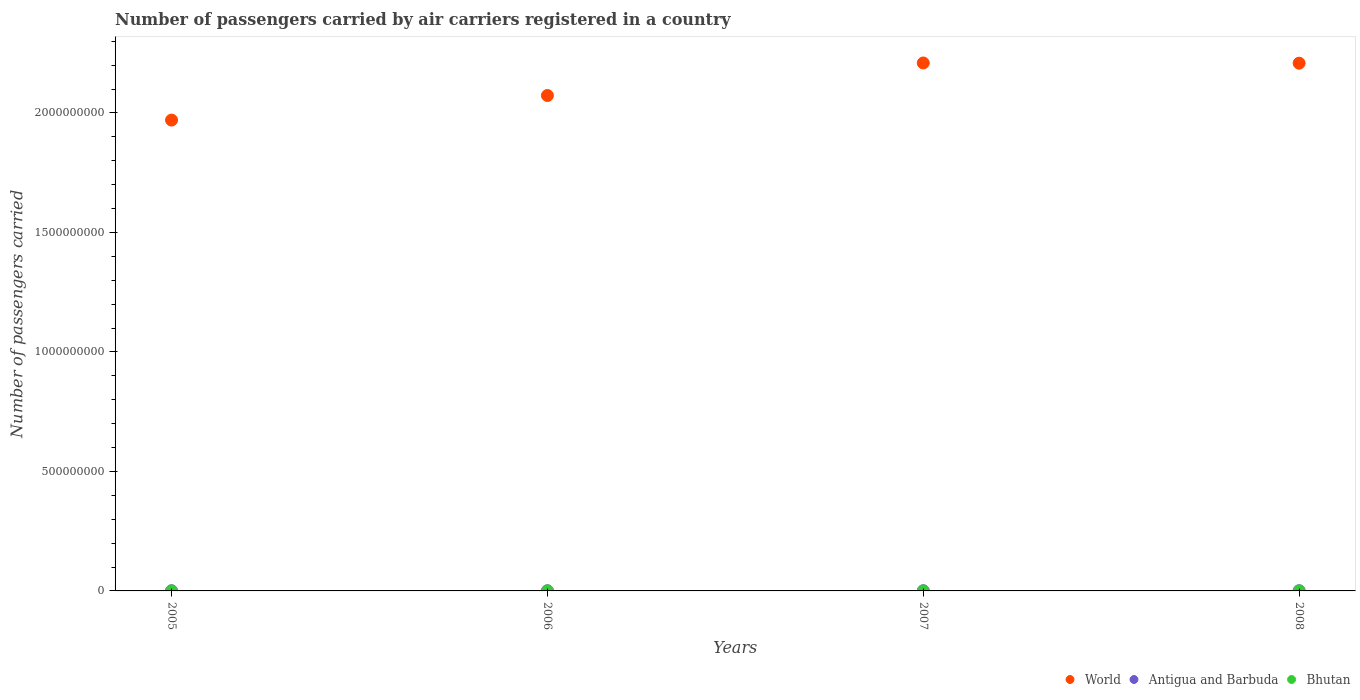How many different coloured dotlines are there?
Keep it short and to the point. 3. What is the number of passengers carried by air carriers in Bhutan in 2008?
Your response must be concise. 5.28e+04. Across all years, what is the maximum number of passengers carried by air carriers in World?
Provide a short and direct response. 2.21e+09. Across all years, what is the minimum number of passengers carried by air carriers in World?
Your answer should be very brief. 1.97e+09. In which year was the number of passengers carried by air carriers in World maximum?
Provide a succinct answer. 2007. What is the total number of passengers carried by air carriers in Antigua and Barbuda in the graph?
Offer a very short reply. 3.15e+06. What is the difference between the number of passengers carried by air carriers in World in 2005 and that in 2007?
Ensure brevity in your answer.  -2.39e+08. What is the difference between the number of passengers carried by air carriers in Antigua and Barbuda in 2006 and the number of passengers carried by air carriers in Bhutan in 2007?
Ensure brevity in your answer.  7.01e+05. What is the average number of passengers carried by air carriers in Antigua and Barbuda per year?
Your answer should be compact. 7.87e+05. In the year 2007, what is the difference between the number of passengers carried by air carriers in World and number of passengers carried by air carriers in Antigua and Barbuda?
Keep it short and to the point. 2.21e+09. What is the ratio of the number of passengers carried by air carriers in Bhutan in 2005 to that in 2007?
Offer a very short reply. 0.92. Is the difference between the number of passengers carried by air carriers in World in 2007 and 2008 greater than the difference between the number of passengers carried by air carriers in Antigua and Barbuda in 2007 and 2008?
Offer a terse response. Yes. What is the difference between the highest and the second highest number of passengers carried by air carriers in World?
Make the answer very short. 9.18e+05. What is the difference between the highest and the lowest number of passengers carried by air carriers in Antigua and Barbuda?
Your response must be concise. 5.81e+04. In how many years, is the number of passengers carried by air carriers in Bhutan greater than the average number of passengers carried by air carriers in Bhutan taken over all years?
Your answer should be compact. 2. Is the number of passengers carried by air carriers in Antigua and Barbuda strictly greater than the number of passengers carried by air carriers in Bhutan over the years?
Offer a terse response. Yes. Is the number of passengers carried by air carriers in Bhutan strictly less than the number of passengers carried by air carriers in Antigua and Barbuda over the years?
Provide a short and direct response. Yes. What is the difference between two consecutive major ticks on the Y-axis?
Your answer should be compact. 5.00e+08. What is the title of the graph?
Provide a short and direct response. Number of passengers carried by air carriers registered in a country. Does "Central African Republic" appear as one of the legend labels in the graph?
Offer a terse response. No. What is the label or title of the X-axis?
Offer a terse response. Years. What is the label or title of the Y-axis?
Your response must be concise. Number of passengers carried. What is the Number of passengers carried of World in 2005?
Your response must be concise. 1.97e+09. What is the Number of passengers carried of Antigua and Barbuda in 2005?
Give a very brief answer. 7.78e+05. What is the Number of passengers carried of Bhutan in 2005?
Keep it short and to the point. 4.91e+04. What is the Number of passengers carried in World in 2006?
Ensure brevity in your answer.  2.07e+09. What is the Number of passengers carried of Antigua and Barbuda in 2006?
Keep it short and to the point. 7.55e+05. What is the Number of passengers carried of Bhutan in 2006?
Keep it short and to the point. 5.11e+04. What is the Number of passengers carried of World in 2007?
Make the answer very short. 2.21e+09. What is the Number of passengers carried of Antigua and Barbuda in 2007?
Provide a succinct answer. 8.00e+05. What is the Number of passengers carried in Bhutan in 2007?
Give a very brief answer. 5.36e+04. What is the Number of passengers carried of World in 2008?
Give a very brief answer. 2.21e+09. What is the Number of passengers carried in Antigua and Barbuda in 2008?
Your answer should be compact. 8.13e+05. What is the Number of passengers carried of Bhutan in 2008?
Keep it short and to the point. 5.28e+04. Across all years, what is the maximum Number of passengers carried of World?
Offer a terse response. 2.21e+09. Across all years, what is the maximum Number of passengers carried in Antigua and Barbuda?
Provide a succinct answer. 8.13e+05. Across all years, what is the maximum Number of passengers carried of Bhutan?
Provide a succinct answer. 5.36e+04. Across all years, what is the minimum Number of passengers carried of World?
Your answer should be compact. 1.97e+09. Across all years, what is the minimum Number of passengers carried in Antigua and Barbuda?
Provide a short and direct response. 7.55e+05. Across all years, what is the minimum Number of passengers carried in Bhutan?
Keep it short and to the point. 4.91e+04. What is the total Number of passengers carried in World in the graph?
Provide a short and direct response. 8.46e+09. What is the total Number of passengers carried of Antigua and Barbuda in the graph?
Your answer should be compact. 3.15e+06. What is the total Number of passengers carried of Bhutan in the graph?
Ensure brevity in your answer.  2.07e+05. What is the difference between the Number of passengers carried of World in 2005 and that in 2006?
Ensure brevity in your answer.  -1.03e+08. What is the difference between the Number of passengers carried of Antigua and Barbuda in 2005 and that in 2006?
Provide a succinct answer. 2.33e+04. What is the difference between the Number of passengers carried in Bhutan in 2005 and that in 2006?
Ensure brevity in your answer.  -1964. What is the difference between the Number of passengers carried of World in 2005 and that in 2007?
Offer a very short reply. -2.39e+08. What is the difference between the Number of passengers carried in Antigua and Barbuda in 2005 and that in 2007?
Your answer should be compact. -2.19e+04. What is the difference between the Number of passengers carried of Bhutan in 2005 and that in 2007?
Keep it short and to the point. -4517. What is the difference between the Number of passengers carried in World in 2005 and that in 2008?
Ensure brevity in your answer.  -2.38e+08. What is the difference between the Number of passengers carried in Antigua and Barbuda in 2005 and that in 2008?
Provide a short and direct response. -3.48e+04. What is the difference between the Number of passengers carried of Bhutan in 2005 and that in 2008?
Your response must be concise. -3713. What is the difference between the Number of passengers carried in World in 2006 and that in 2007?
Your answer should be very brief. -1.36e+08. What is the difference between the Number of passengers carried of Antigua and Barbuda in 2006 and that in 2007?
Provide a succinct answer. -4.53e+04. What is the difference between the Number of passengers carried in Bhutan in 2006 and that in 2007?
Your answer should be compact. -2553. What is the difference between the Number of passengers carried in World in 2006 and that in 2008?
Ensure brevity in your answer.  -1.35e+08. What is the difference between the Number of passengers carried of Antigua and Barbuda in 2006 and that in 2008?
Your response must be concise. -5.81e+04. What is the difference between the Number of passengers carried in Bhutan in 2006 and that in 2008?
Ensure brevity in your answer.  -1749. What is the difference between the Number of passengers carried in World in 2007 and that in 2008?
Provide a succinct answer. 9.18e+05. What is the difference between the Number of passengers carried in Antigua and Barbuda in 2007 and that in 2008?
Keep it short and to the point. -1.28e+04. What is the difference between the Number of passengers carried of Bhutan in 2007 and that in 2008?
Your response must be concise. 804. What is the difference between the Number of passengers carried of World in 2005 and the Number of passengers carried of Antigua and Barbuda in 2006?
Give a very brief answer. 1.97e+09. What is the difference between the Number of passengers carried in World in 2005 and the Number of passengers carried in Bhutan in 2006?
Make the answer very short. 1.97e+09. What is the difference between the Number of passengers carried in Antigua and Barbuda in 2005 and the Number of passengers carried in Bhutan in 2006?
Your answer should be compact. 7.27e+05. What is the difference between the Number of passengers carried of World in 2005 and the Number of passengers carried of Antigua and Barbuda in 2007?
Offer a terse response. 1.97e+09. What is the difference between the Number of passengers carried in World in 2005 and the Number of passengers carried in Bhutan in 2007?
Make the answer very short. 1.97e+09. What is the difference between the Number of passengers carried in Antigua and Barbuda in 2005 and the Number of passengers carried in Bhutan in 2007?
Keep it short and to the point. 7.25e+05. What is the difference between the Number of passengers carried in World in 2005 and the Number of passengers carried in Antigua and Barbuda in 2008?
Ensure brevity in your answer.  1.97e+09. What is the difference between the Number of passengers carried in World in 2005 and the Number of passengers carried in Bhutan in 2008?
Your response must be concise. 1.97e+09. What is the difference between the Number of passengers carried in Antigua and Barbuda in 2005 and the Number of passengers carried in Bhutan in 2008?
Your answer should be compact. 7.25e+05. What is the difference between the Number of passengers carried in World in 2006 and the Number of passengers carried in Antigua and Barbuda in 2007?
Offer a terse response. 2.07e+09. What is the difference between the Number of passengers carried of World in 2006 and the Number of passengers carried of Bhutan in 2007?
Provide a short and direct response. 2.07e+09. What is the difference between the Number of passengers carried of Antigua and Barbuda in 2006 and the Number of passengers carried of Bhutan in 2007?
Provide a succinct answer. 7.01e+05. What is the difference between the Number of passengers carried in World in 2006 and the Number of passengers carried in Antigua and Barbuda in 2008?
Ensure brevity in your answer.  2.07e+09. What is the difference between the Number of passengers carried of World in 2006 and the Number of passengers carried of Bhutan in 2008?
Give a very brief answer. 2.07e+09. What is the difference between the Number of passengers carried of Antigua and Barbuda in 2006 and the Number of passengers carried of Bhutan in 2008?
Offer a very short reply. 7.02e+05. What is the difference between the Number of passengers carried of World in 2007 and the Number of passengers carried of Antigua and Barbuda in 2008?
Offer a terse response. 2.21e+09. What is the difference between the Number of passengers carried in World in 2007 and the Number of passengers carried in Bhutan in 2008?
Ensure brevity in your answer.  2.21e+09. What is the difference between the Number of passengers carried of Antigua and Barbuda in 2007 and the Number of passengers carried of Bhutan in 2008?
Provide a short and direct response. 7.47e+05. What is the average Number of passengers carried in World per year?
Ensure brevity in your answer.  2.12e+09. What is the average Number of passengers carried in Antigua and Barbuda per year?
Your response must be concise. 7.87e+05. What is the average Number of passengers carried of Bhutan per year?
Ensure brevity in your answer.  5.16e+04. In the year 2005, what is the difference between the Number of passengers carried of World and Number of passengers carried of Antigua and Barbuda?
Offer a very short reply. 1.97e+09. In the year 2005, what is the difference between the Number of passengers carried of World and Number of passengers carried of Bhutan?
Offer a terse response. 1.97e+09. In the year 2005, what is the difference between the Number of passengers carried of Antigua and Barbuda and Number of passengers carried of Bhutan?
Offer a very short reply. 7.29e+05. In the year 2006, what is the difference between the Number of passengers carried of World and Number of passengers carried of Antigua and Barbuda?
Keep it short and to the point. 2.07e+09. In the year 2006, what is the difference between the Number of passengers carried of World and Number of passengers carried of Bhutan?
Keep it short and to the point. 2.07e+09. In the year 2006, what is the difference between the Number of passengers carried in Antigua and Barbuda and Number of passengers carried in Bhutan?
Your response must be concise. 7.04e+05. In the year 2007, what is the difference between the Number of passengers carried of World and Number of passengers carried of Antigua and Barbuda?
Provide a short and direct response. 2.21e+09. In the year 2007, what is the difference between the Number of passengers carried of World and Number of passengers carried of Bhutan?
Ensure brevity in your answer.  2.21e+09. In the year 2007, what is the difference between the Number of passengers carried in Antigua and Barbuda and Number of passengers carried in Bhutan?
Provide a succinct answer. 7.47e+05. In the year 2008, what is the difference between the Number of passengers carried in World and Number of passengers carried in Antigua and Barbuda?
Keep it short and to the point. 2.21e+09. In the year 2008, what is the difference between the Number of passengers carried of World and Number of passengers carried of Bhutan?
Give a very brief answer. 2.21e+09. In the year 2008, what is the difference between the Number of passengers carried of Antigua and Barbuda and Number of passengers carried of Bhutan?
Keep it short and to the point. 7.60e+05. What is the ratio of the Number of passengers carried in World in 2005 to that in 2006?
Ensure brevity in your answer.  0.95. What is the ratio of the Number of passengers carried of Antigua and Barbuda in 2005 to that in 2006?
Offer a very short reply. 1.03. What is the ratio of the Number of passengers carried of Bhutan in 2005 to that in 2006?
Your answer should be very brief. 0.96. What is the ratio of the Number of passengers carried of World in 2005 to that in 2007?
Offer a terse response. 0.89. What is the ratio of the Number of passengers carried in Antigua and Barbuda in 2005 to that in 2007?
Offer a terse response. 0.97. What is the ratio of the Number of passengers carried of Bhutan in 2005 to that in 2007?
Your response must be concise. 0.92. What is the ratio of the Number of passengers carried in World in 2005 to that in 2008?
Offer a terse response. 0.89. What is the ratio of the Number of passengers carried in Antigua and Barbuda in 2005 to that in 2008?
Offer a very short reply. 0.96. What is the ratio of the Number of passengers carried in Bhutan in 2005 to that in 2008?
Your answer should be very brief. 0.93. What is the ratio of the Number of passengers carried of World in 2006 to that in 2007?
Offer a very short reply. 0.94. What is the ratio of the Number of passengers carried in Antigua and Barbuda in 2006 to that in 2007?
Ensure brevity in your answer.  0.94. What is the ratio of the Number of passengers carried in World in 2006 to that in 2008?
Give a very brief answer. 0.94. What is the ratio of the Number of passengers carried of Antigua and Barbuda in 2006 to that in 2008?
Your answer should be very brief. 0.93. What is the ratio of the Number of passengers carried of Bhutan in 2006 to that in 2008?
Provide a succinct answer. 0.97. What is the ratio of the Number of passengers carried of Antigua and Barbuda in 2007 to that in 2008?
Make the answer very short. 0.98. What is the ratio of the Number of passengers carried in Bhutan in 2007 to that in 2008?
Provide a succinct answer. 1.02. What is the difference between the highest and the second highest Number of passengers carried of World?
Your answer should be compact. 9.18e+05. What is the difference between the highest and the second highest Number of passengers carried in Antigua and Barbuda?
Make the answer very short. 1.28e+04. What is the difference between the highest and the second highest Number of passengers carried in Bhutan?
Provide a succinct answer. 804. What is the difference between the highest and the lowest Number of passengers carried of World?
Your answer should be compact. 2.39e+08. What is the difference between the highest and the lowest Number of passengers carried of Antigua and Barbuda?
Your answer should be very brief. 5.81e+04. What is the difference between the highest and the lowest Number of passengers carried of Bhutan?
Provide a succinct answer. 4517. 